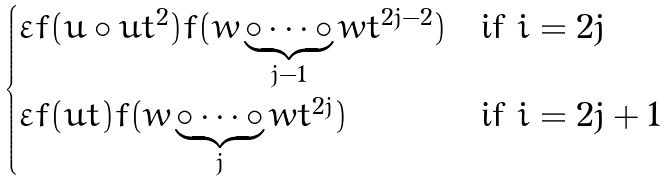Convert formula to latex. <formula><loc_0><loc_0><loc_500><loc_500>\begin{cases} \varepsilon f ( u \circ u t ^ { 2 } ) f ( w \underbrace { \circ \cdots \circ } _ { j - 1 } w t ^ { 2 j - 2 } ) & \text {if $i=2j$} \\ \varepsilon f ( u t ) f ( w \underbrace { \circ \cdots \circ } _ { j } w t ^ { 2 j } ) & \text {if $i=2j+1$} \end{cases}</formula> 